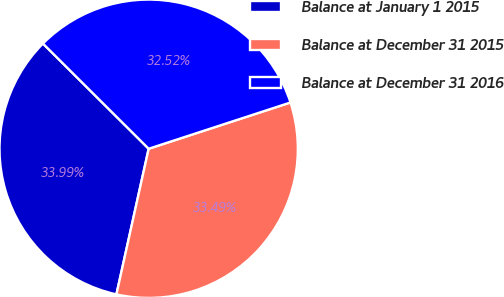Convert chart. <chart><loc_0><loc_0><loc_500><loc_500><pie_chart><fcel>Balance at January 1 2015<fcel>Balance at December 31 2015<fcel>Balance at December 31 2016<nl><fcel>33.99%<fcel>33.49%<fcel>32.52%<nl></chart> 